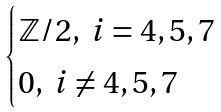Convert formula to latex. <formula><loc_0><loc_0><loc_500><loc_500>\begin{cases} \mathbb { Z } / 2 , \ i = 4 , 5 , 7 \\ 0 , \ i \neq 4 , 5 , 7 \end{cases}</formula> 